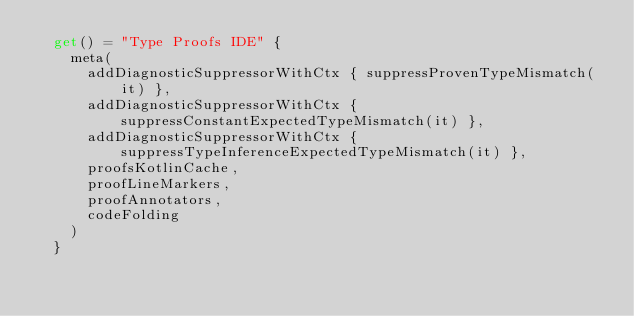Convert code to text. <code><loc_0><loc_0><loc_500><loc_500><_Kotlin_>  get() = "Type Proofs IDE" {
    meta(
      addDiagnosticSuppressorWithCtx { suppressProvenTypeMismatch(it) },
      addDiagnosticSuppressorWithCtx { suppressConstantExpectedTypeMismatch(it) },
      addDiagnosticSuppressorWithCtx { suppressTypeInferenceExpectedTypeMismatch(it) },
      proofsKotlinCache,
      proofLineMarkers,
      proofAnnotators,
      codeFolding
    )
  }
</code> 